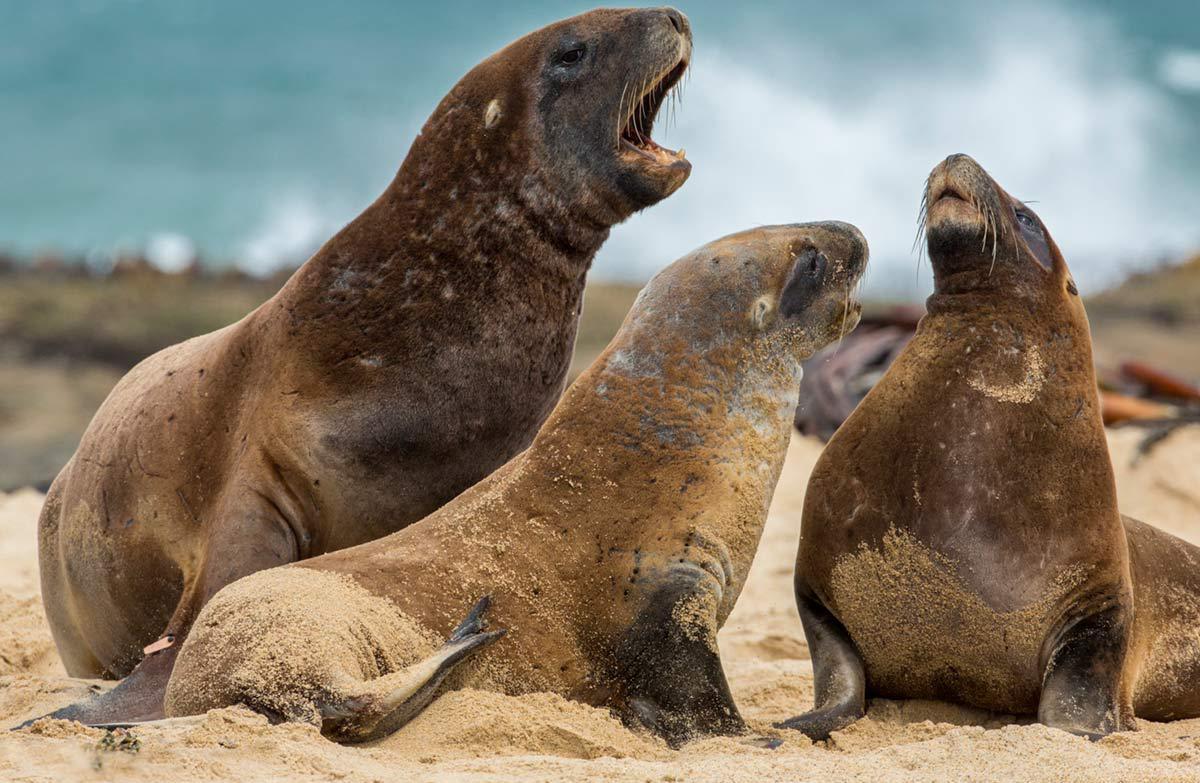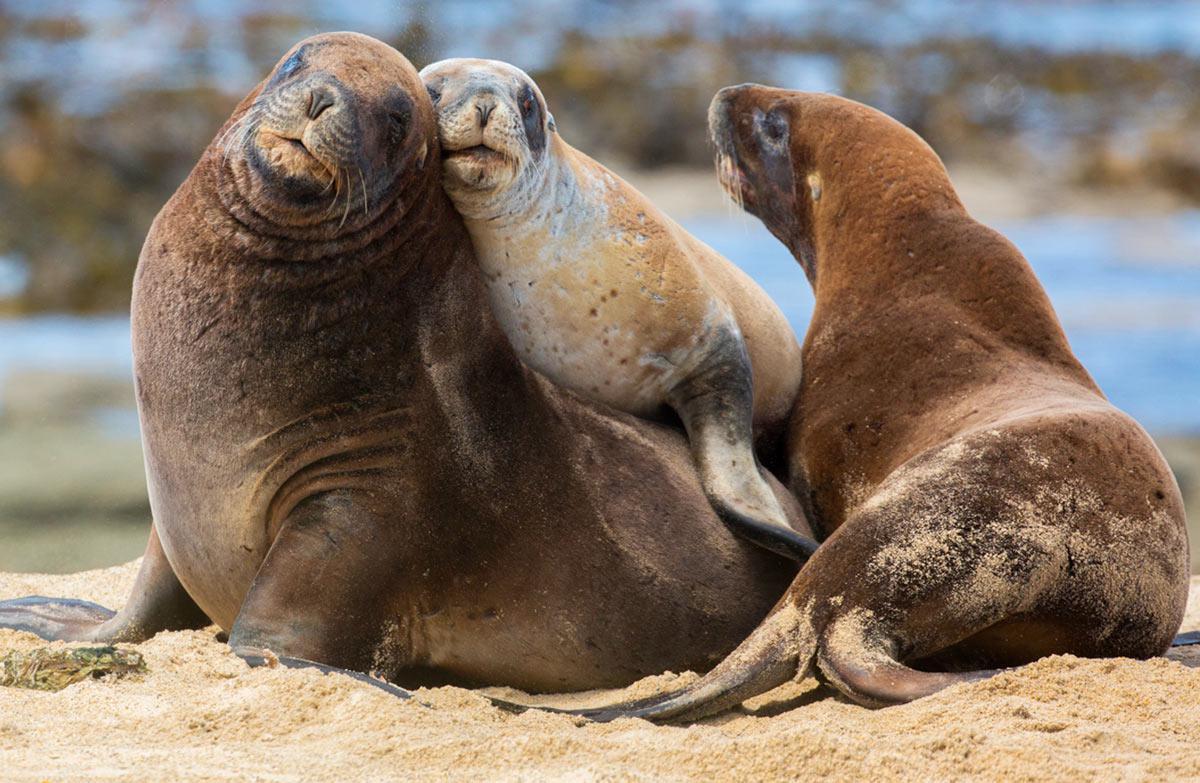The first image is the image on the left, the second image is the image on the right. Given the left and right images, does the statement "An image shows at least one small dark seal pup next to a larger paler adult seal." hold true? Answer yes or no. No. The first image is the image on the left, the second image is the image on the right. For the images shown, is this caption "There are exactly three animals in the image on the right." true? Answer yes or no. Yes. 